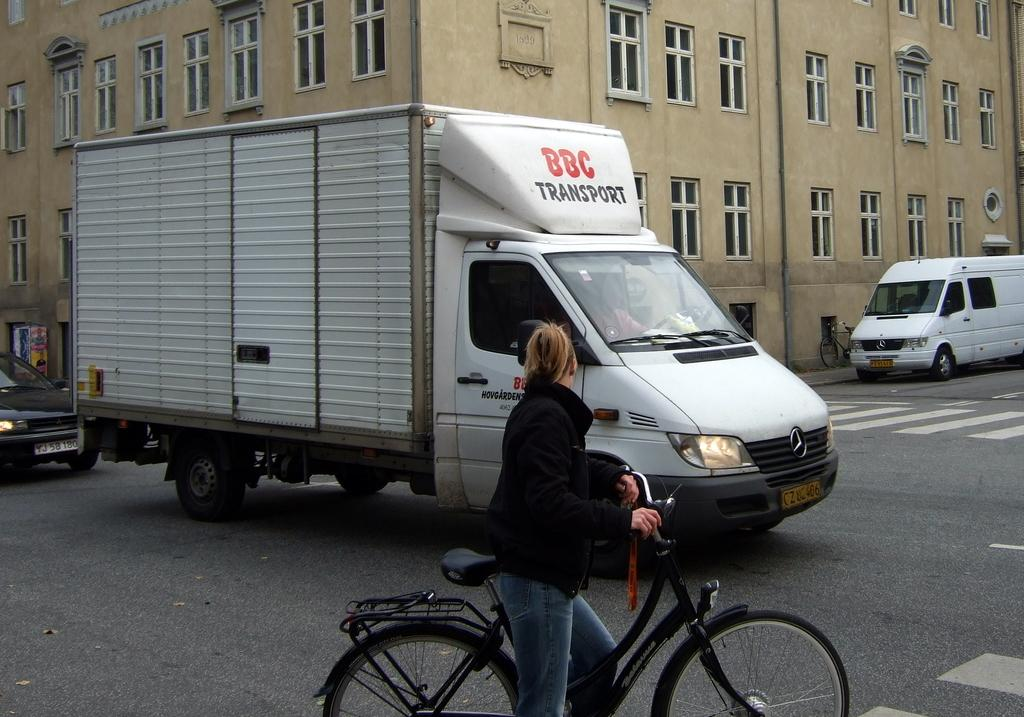<image>
Describe the image concisely. a van that has the letters BBC on it 